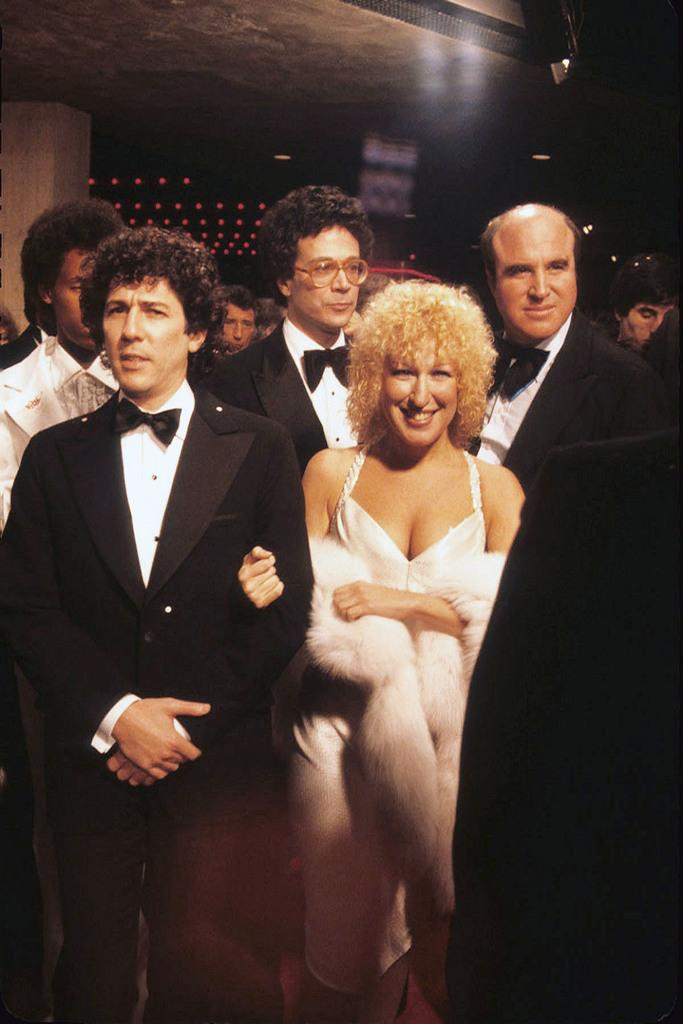How many people are in the image? There are persons standing in the image, but the exact number is not specified. What is the color of the background in the image? The background of the image is dark. What type of lighting is present in the image? There are lights on the ceiling, pillars, and other objects in the image. Can you see a mint plant growing on the floor in the image? There is no mention of a mint plant or any plants in the image. 